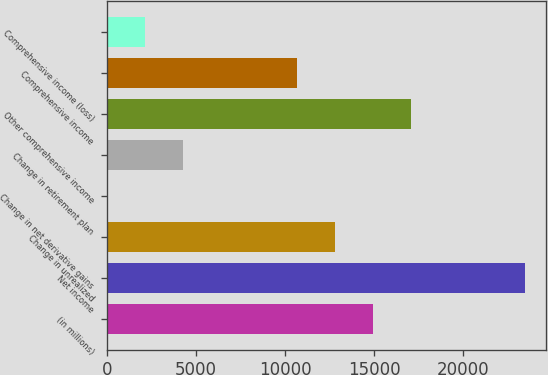Convert chart. <chart><loc_0><loc_0><loc_500><loc_500><bar_chart><fcel>(in millions)<fcel>Net income<fcel>Change in unrealized<fcel>Change in net derivative gains<fcel>Change in retirement plan<fcel>Other comprehensive income<fcel>Comprehensive income<fcel>Comprehensive income (loss)<nl><fcel>14936.1<fcel>23461.3<fcel>12804.8<fcel>17<fcel>4279.6<fcel>17067.4<fcel>10673.5<fcel>2148.3<nl></chart> 